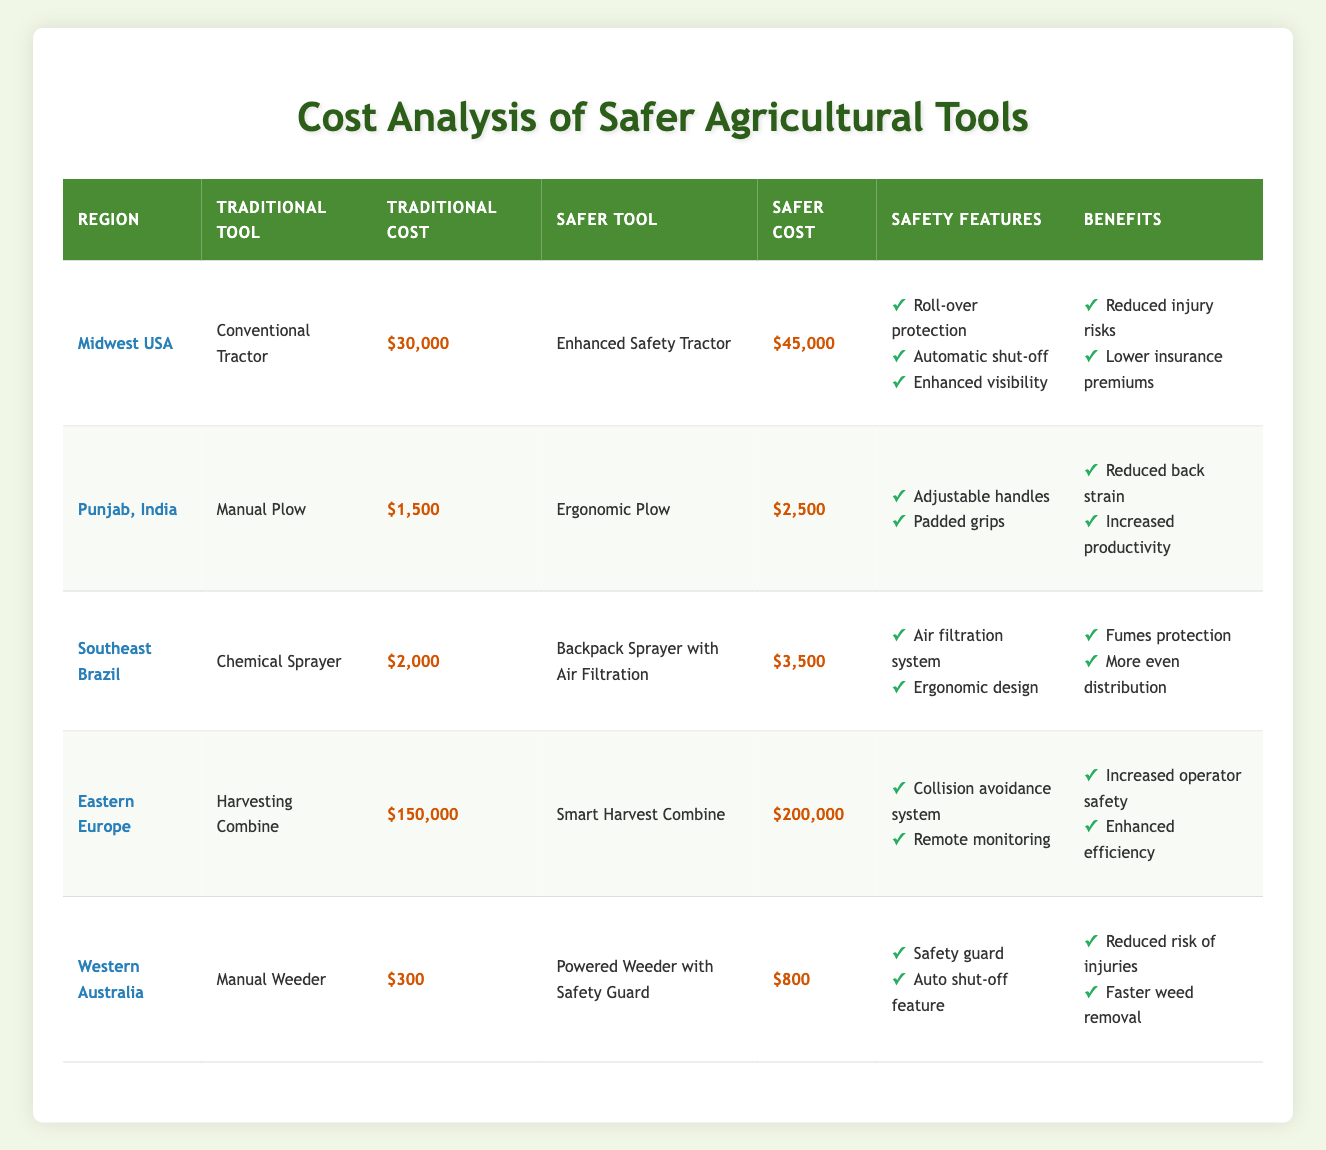What is the cost difference between the safer tool and the traditional tool in the Midwest USA? The traditional tool cost is $30,000 and the safer tool cost is $45,000. The difference is calculated as $45,000 - $30,000 = $15,000.
Answer: $15,000 Which region has the highest cost for the traditional tool? Looking at the table, Eastern Europe shows a traditional tool cost of $150,000, which is higher than other regions.
Answer: Eastern Europe Are the safety features of the Backpack Sprayer with Air Filtration mentioned in the table? Yes, the table lists the safety features for the Backpack Sprayer with Air Filtration as "Air filtration system" and "Ergonomic design."
Answer: Yes What is the average cost of the safer tools across all regions? First, sum the safer tool costs: $45,000 + $2,500 + $3,500 + $200,000 + $800 = $252,800. There are 5 regions, so the average is $252,800 / 5 = $50,560.
Answer: $50,560 Does any region show a traditional tool that costs less than $1,000? By examining all the traditional tool costs in the table, no region shows a cost below $1,000; the lowest is $300 from the Manual Weeder in Western Australia.
Answer: No Which safer tool offers the most extensive safety features according to the table? The table indicates that the Smart Harvest Combine in Eastern Europe has safety features including "Collision avoidance system" and "Remote monitoring," which may provide more comprehensive protection.
Answer: Smart Harvest Combine What is the combined cost of the traditional tools in Punjab, India and Western Australia? The traditional tool costs are $1,500 (Punjab) and $300 (Western Australia). Combine these two amounts: $1,500 + $300 = $1,800.
Answer: $1,800 Which region has the lowest cost for a traditional tool and what is that cost? Western Australia has the lowest cost of $300 for the Manual Weeder. This can be verified by comparing all regions’ traditional tool costs in the table.
Answer: Western Australia, $300 Is the Enhanced Safety Tractor more expensive than the Smart Harvest Combine? The Enhanced Safety Tractor costs $45,000, while the Smart Harvest Combine costs $200,000. Since $45,000 is less than $200,000, the statement is false.
Answer: No 